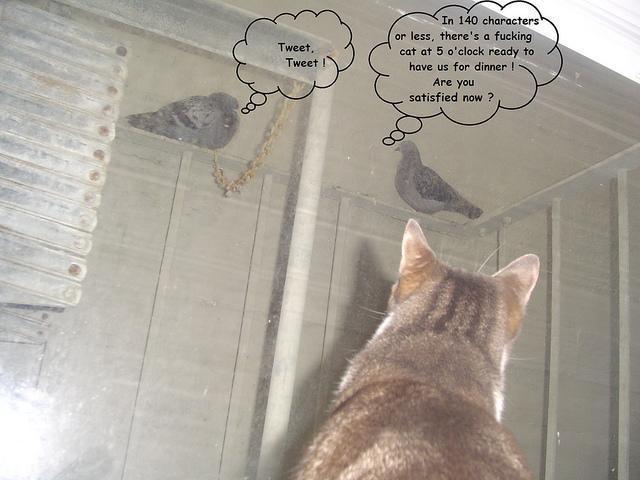The dialogue bubbles are an example of what editing technique?
Indicate the correct response by choosing from the four available options to answer the question.
Options: Hue, superimposition, opacity, masking. Superimposition. 